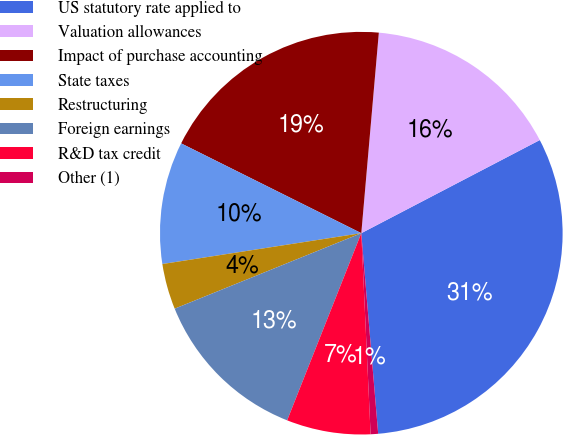Convert chart. <chart><loc_0><loc_0><loc_500><loc_500><pie_chart><fcel>US statutory rate applied to<fcel>Valuation allowances<fcel>Impact of purchase accounting<fcel>State taxes<fcel>Restructuring<fcel>Foreign earnings<fcel>R&D tax credit<fcel>Other (1)<nl><fcel>31.32%<fcel>15.96%<fcel>19.03%<fcel>9.81%<fcel>3.67%<fcel>12.88%<fcel>6.74%<fcel>0.6%<nl></chart> 